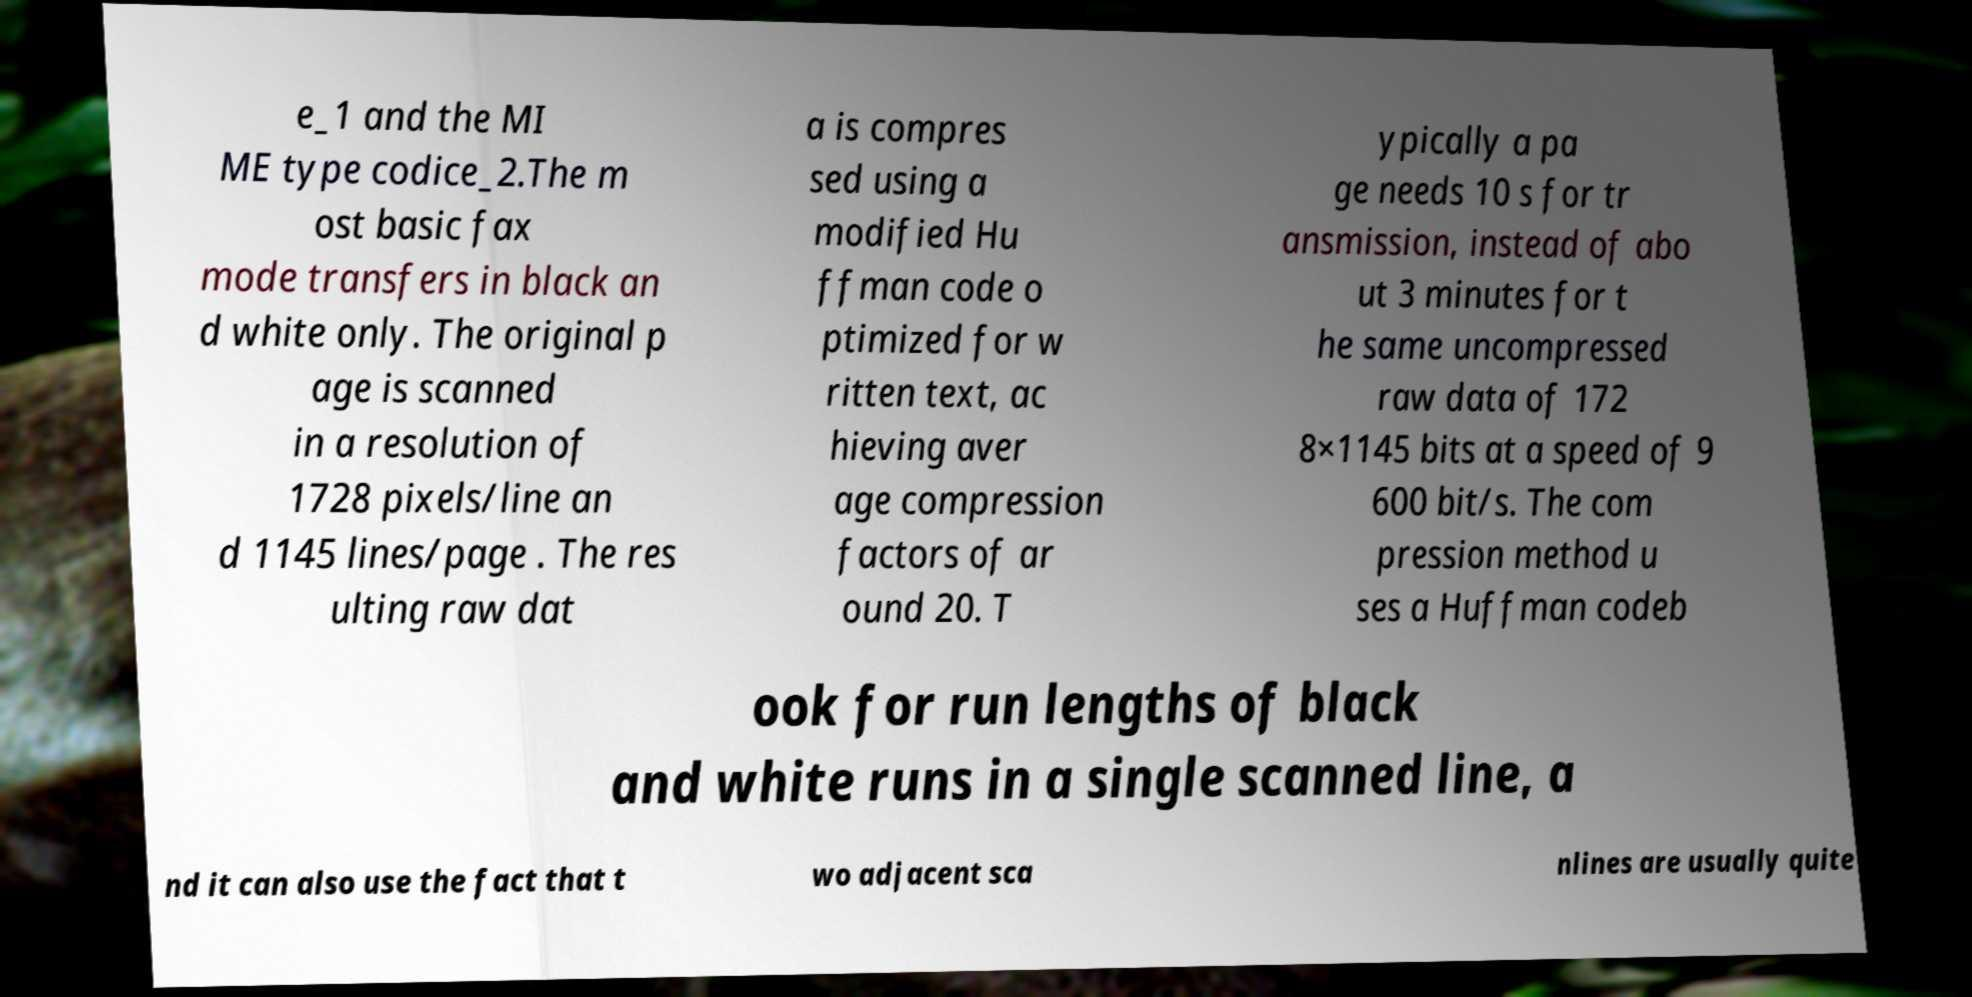Please identify and transcribe the text found in this image. e_1 and the MI ME type codice_2.The m ost basic fax mode transfers in black an d white only. The original p age is scanned in a resolution of 1728 pixels/line an d 1145 lines/page . The res ulting raw dat a is compres sed using a modified Hu ffman code o ptimized for w ritten text, ac hieving aver age compression factors of ar ound 20. T ypically a pa ge needs 10 s for tr ansmission, instead of abo ut 3 minutes for t he same uncompressed raw data of 172 8×1145 bits at a speed of 9 600 bit/s. The com pression method u ses a Huffman codeb ook for run lengths of black and white runs in a single scanned line, a nd it can also use the fact that t wo adjacent sca nlines are usually quite 